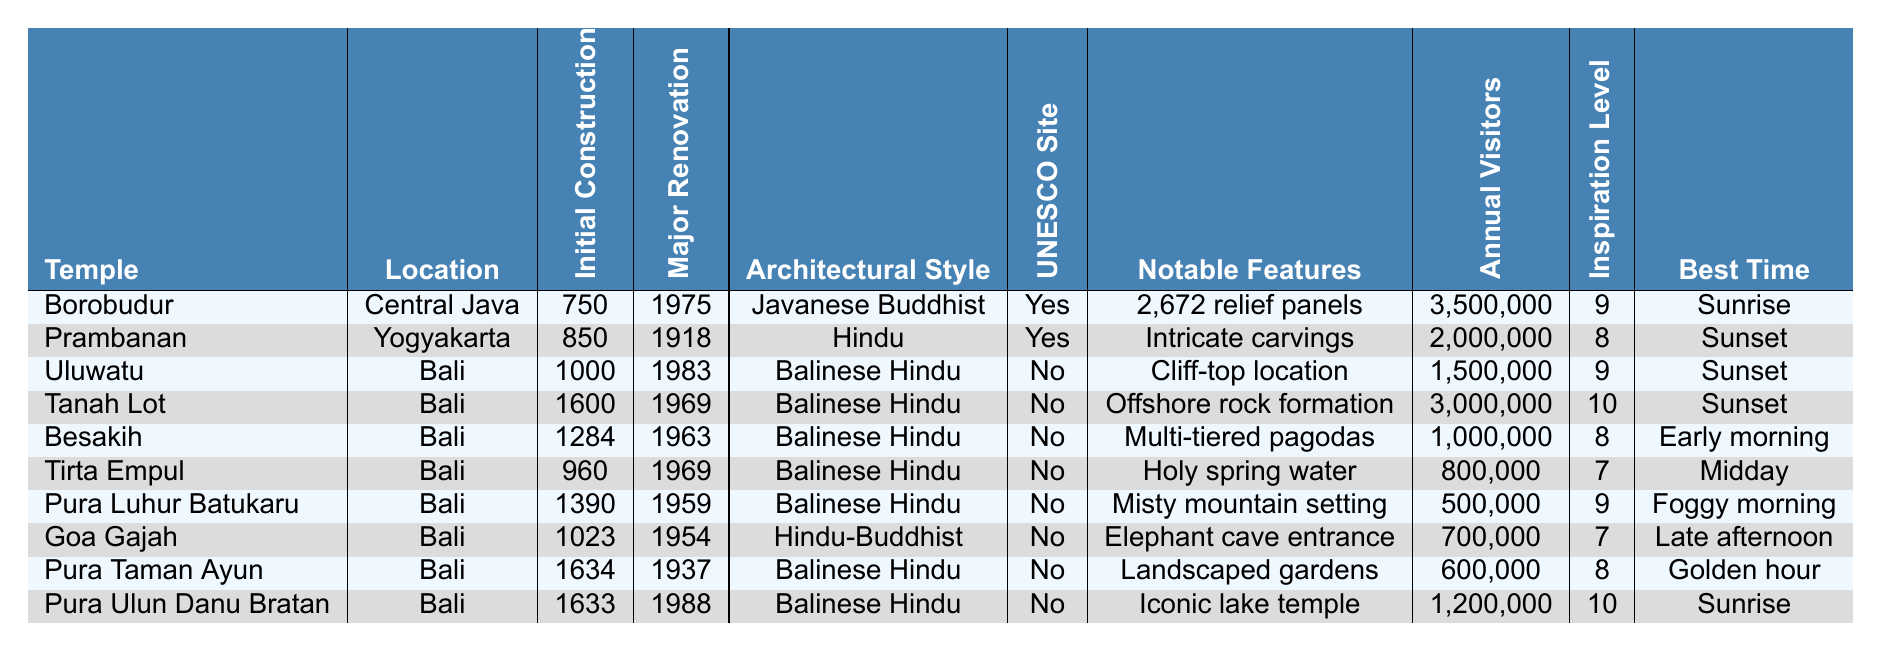What is the architectural style of Borobudur? The architectural style for Borobudur is listed in the table under the relevant column, which shows "Javanese Buddhist."
Answer: Javanese Buddhist In which year was the major renovation of Prambanan completed? The table indicates that the major renovation year for Prambanan is 1918, as mentioned in the corresponding column.
Answer: 1918 How many estimated annual visitors does Tanah Lot receive? The estimated annual visitors for Tanah Lot are provided in the table, showing a value of 3,000,000.
Answer: 3,000,000 Which temple has the highest inspiration level for artists? To find the highest inspiration level, we look at the "Inspiration Level for Artists" column. The highest value is 10, associated with both Tanah Lot and Pura Ulun Danu Bratan, but we only need one.
Answer: Tanah Lot Is Uluwatu a UNESCO World Heritage Site? The table specifies that Uluwatu is not a UNESCO World Heritage Site, which is indicated by "No" in the respective column.
Answer: No What is the difference in initial construction year between Goa Gajah and Pura Taman Ayun? The initial construction year for Goa Gajah is 1023 and for Pura Taman Ayun is 1634. To find the difference, we calculate 1634 - 1023 = 611.
Answer: 611 How many temples have an estimated annual visitor count of over 2 million? We examine the "Estimated Annual Visitors" column and count the temples with visitor counts greater than 2 million. These are Borobudur (3,500,000), Tanah Lot (3,000,000), and Prambanan (2,000,000), totaling 3 temples.
Answer: 3 What is the average inspiration level for artists among the temples located in Bali? The temples located in Bali are Uluwatu (9), Tanah Lot (10), Besakih (8), Tirta Empul (7), Pura Luhur Batukaru (9), Goa Gajah (7), Pura Taman Ayun (8), and Pura Ulun Danu Bratan (10). The total is 9 + 10 + 8 + 7 + 9 + 7 + 8 + 10 = 78. There are 8 temples, so the average is 78/8 = 9.75.
Answer: 9.75 Which temple in Bali has the iconic lake temple as a notable artistic feature? In the table, "Pura Ulun Danu Bratan" is noted for having the "Iconic lake temple" listed as its notable artistic feature.
Answer: Pura Ulun Danu Bratan How many temples were constructed before the year 1000? The initial construction years listed for the temples (Borobudur, Prambanan, and Uluwatu) show that Borobudur (750) and Prambanan (850) were built before 1000. Thus, there are 2 temples before the year 1000.
Answer: 2 